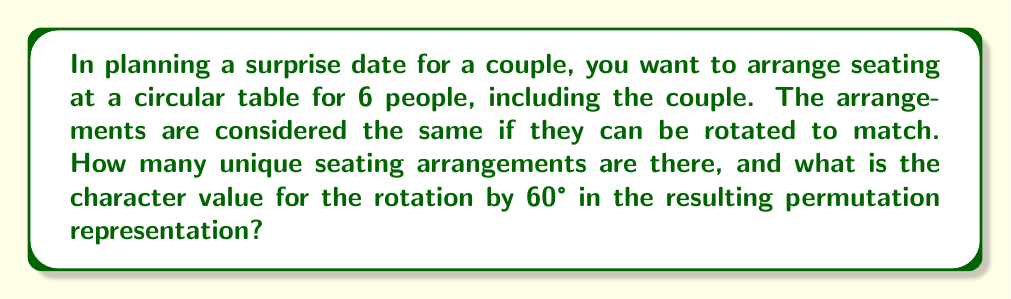Solve this math problem. Let's approach this step-by-step:

1) First, we need to determine the number of unique seating arrangements. This is a classic circular permutation problem.

   - For a linear arrangement of 6 people, we would have 6! permutations.
   - However, in a circular arrangement, rotations are considered the same.
   - Thus, we divide by the number of rotations possible (6 in this case).
   - The number of unique arrangements is: $\frac{6!}{6} = 5! = 120$

2) Now, we need to consider the permutation representation of the cyclic group $C_6$ acting on these 120 arrangements.

3) To find the character value for a 60° rotation (let's call this element $g$), we need to count the number of arrangements fixed by this rotation.

4) A 60° rotation is equivalent to shifting each person one seat to the left (or right).

5) For an arrangement to be fixed by this rotation, it must have a repeating pattern every 60°. The only way this can happen is if the same person occupies every seat, which is impossible.

6) Therefore, no arrangements are fixed by a 60° rotation.

7) In character theory, the character value for an element $g$ in a permutation representation is the number of elements fixed by $g$.

8) Since no arrangements are fixed by the 60° rotation, the character value is 0.
Answer: 0 